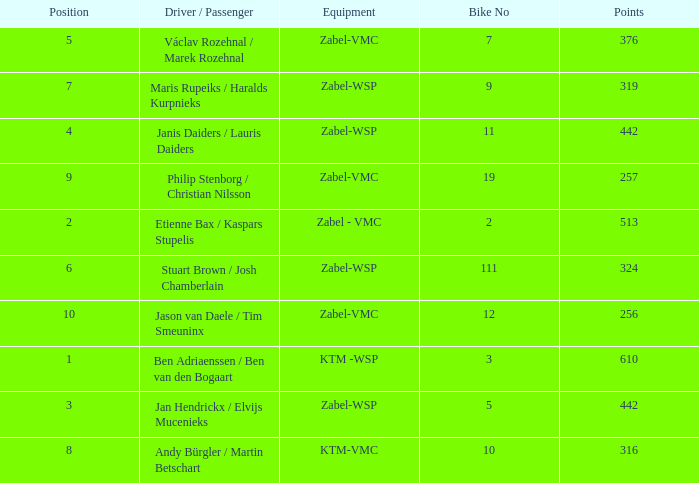What is the Equipment that has a Point bigger than 256, and a Position of 3? Zabel-WSP. 